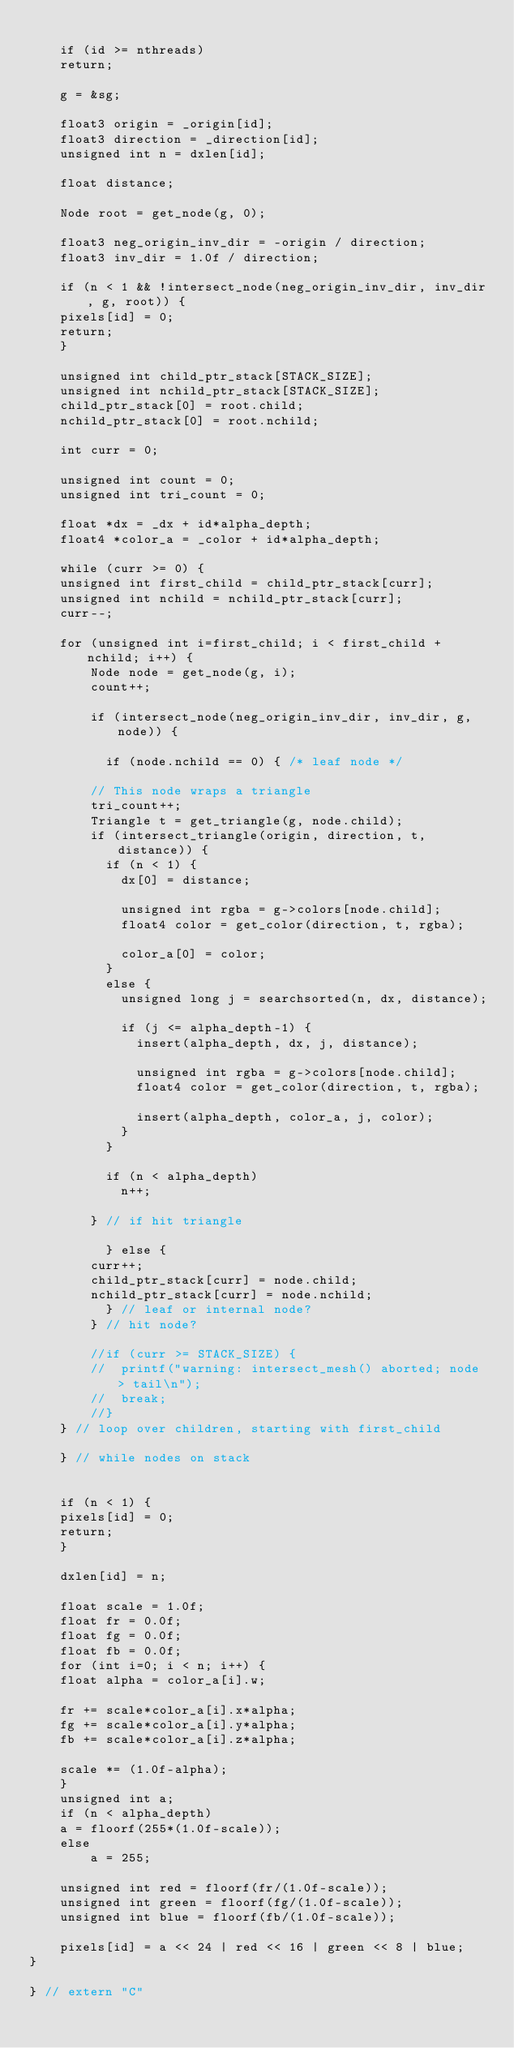<code> <loc_0><loc_0><loc_500><loc_500><_Cuda_>	
    if (id >= nthreads)
	return;

    g = &sg;

    float3 origin = _origin[id];
    float3 direction = _direction[id];
    unsigned int n = dxlen[id];

    float distance;

    Node root = get_node(g, 0);

    float3 neg_origin_inv_dir = -origin / direction;
    float3 inv_dir = 1.0f / direction;

    if (n < 1 && !intersect_node(neg_origin_inv_dir, inv_dir, g, root)) {
	pixels[id] = 0;
	return;
    }

    unsigned int child_ptr_stack[STACK_SIZE];
    unsigned int nchild_ptr_stack[STACK_SIZE];
    child_ptr_stack[0] = root.child;
    nchild_ptr_stack[0] = root.nchild;

    int curr = 0;

    unsigned int count = 0;
    unsigned int tri_count = 0;

    float *dx = _dx + id*alpha_depth;
    float4 *color_a = _color + id*alpha_depth;

    while (curr >= 0) {
	unsigned int first_child = child_ptr_stack[curr];
	unsigned int nchild = nchild_ptr_stack[curr];
	curr--;

	for (unsigned int i=first_child; i < first_child + nchild; i++) {
	    Node node = get_node(g, i);
	    count++;

	    if (intersect_node(neg_origin_inv_dir, inv_dir, g, node)) {

	      if (node.nchild == 0) { /* leaf node */

		// This node wraps a triangle
		tri_count++;
		Triangle t = get_triangle(g, node.child);
		if (intersect_triangle(origin, direction, t, distance)) {
		  if (n < 1) {
		    dx[0] = distance;
		    
		    unsigned int rgba = g->colors[node.child];
		    float4 color = get_color(direction, t, rgba);
		    
		    color_a[0] = color;
		  }
		  else {
		    unsigned long j = searchsorted(n, dx, distance);
		    
		    if (j <= alpha_depth-1) {
		      insert(alpha_depth, dx, j, distance);
		      
		      unsigned int rgba = g->colors[node.child];
		      float4 color = get_color(direction, t, rgba);
		      
		      insert(alpha_depth, color_a, j, color);
		    }
		  }
		  
		  if (n < alpha_depth)
		    n++;
		  
		} // if hit triangle
		
	      } else {
		curr++;
		child_ptr_stack[curr] = node.child;
		nchild_ptr_stack[curr] = node.nchild;
	      } // leaf or internal node?
	    } // hit node?
	    
	    //if (curr >= STACK_SIZE) {
	    //	printf("warning: intersect_mesh() aborted; node > tail\n");
	    //	break;
	    //}
	} // loop over children, starting with first_child
	
    } // while nodes on stack
    

    if (n < 1) {
	pixels[id] = 0;
	return;
    }

    dxlen[id] = n;

    float scale = 1.0f;
    float fr = 0.0f;
    float fg = 0.0f;
    float fb = 0.0f;
    for (int i=0; i < n; i++) {
	float alpha = color_a[i].w;
	
	fr += scale*color_a[i].x*alpha;
	fg += scale*color_a[i].y*alpha;
	fb += scale*color_a[i].z*alpha;
	
	scale *= (1.0f-alpha);
    }
    unsigned int a;
    if (n < alpha_depth)
	a = floorf(255*(1.0f-scale));
    else
    	a = 255;

    unsigned int red = floorf(fr/(1.0f-scale));
    unsigned int green = floorf(fg/(1.0f-scale));
    unsigned int blue = floorf(fb/(1.0f-scale));

    pixels[id] = a << 24 | red << 16 | green << 8 | blue;
}

} // extern "C"
</code> 